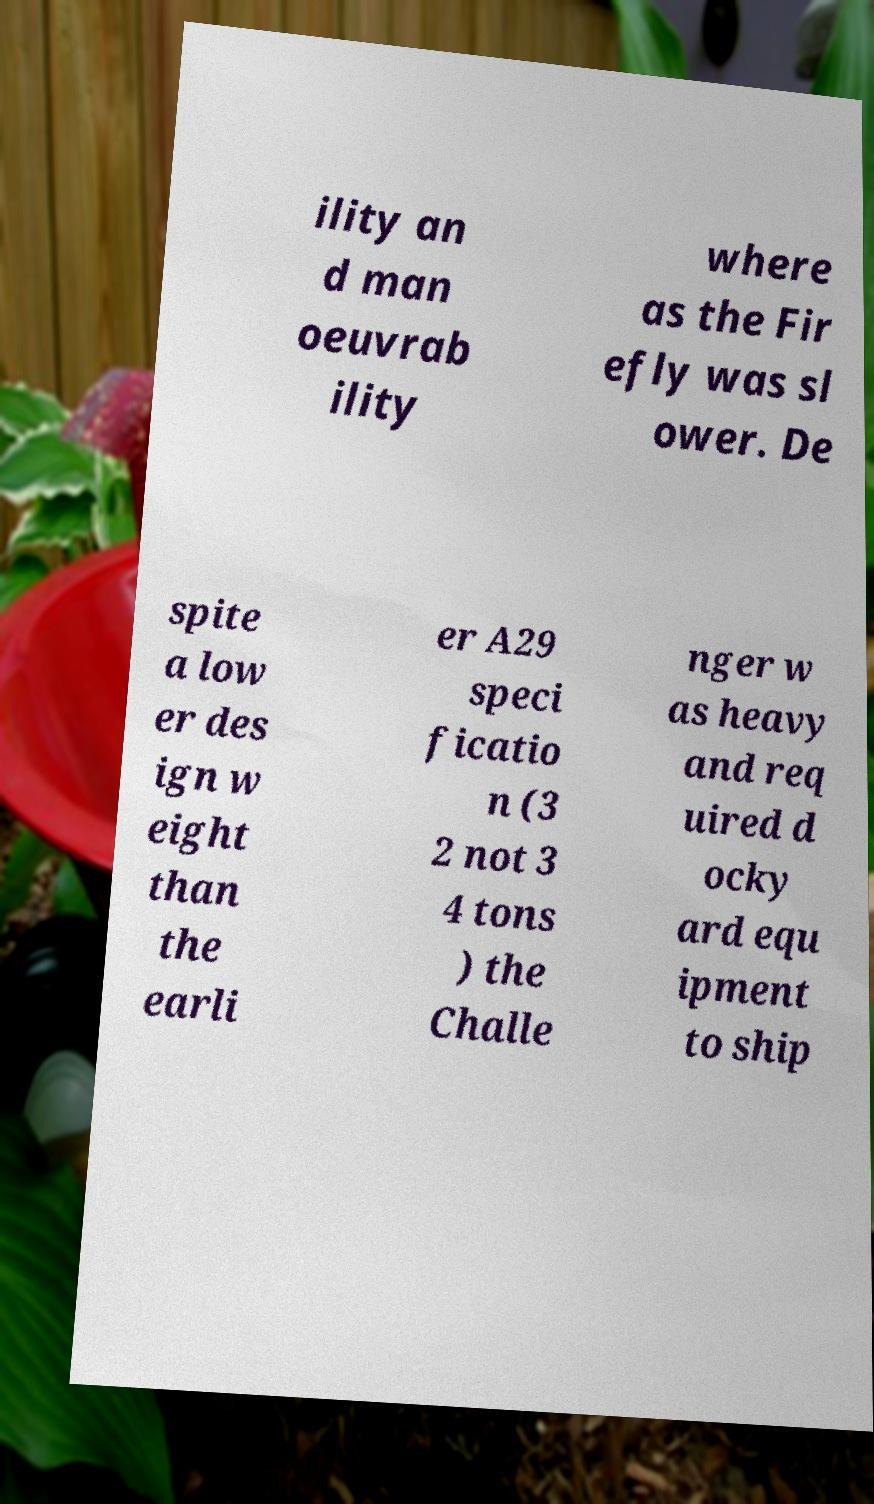For documentation purposes, I need the text within this image transcribed. Could you provide that? ility an d man oeuvrab ility where as the Fir efly was sl ower. De spite a low er des ign w eight than the earli er A29 speci ficatio n (3 2 not 3 4 tons ) the Challe nger w as heavy and req uired d ocky ard equ ipment to ship 